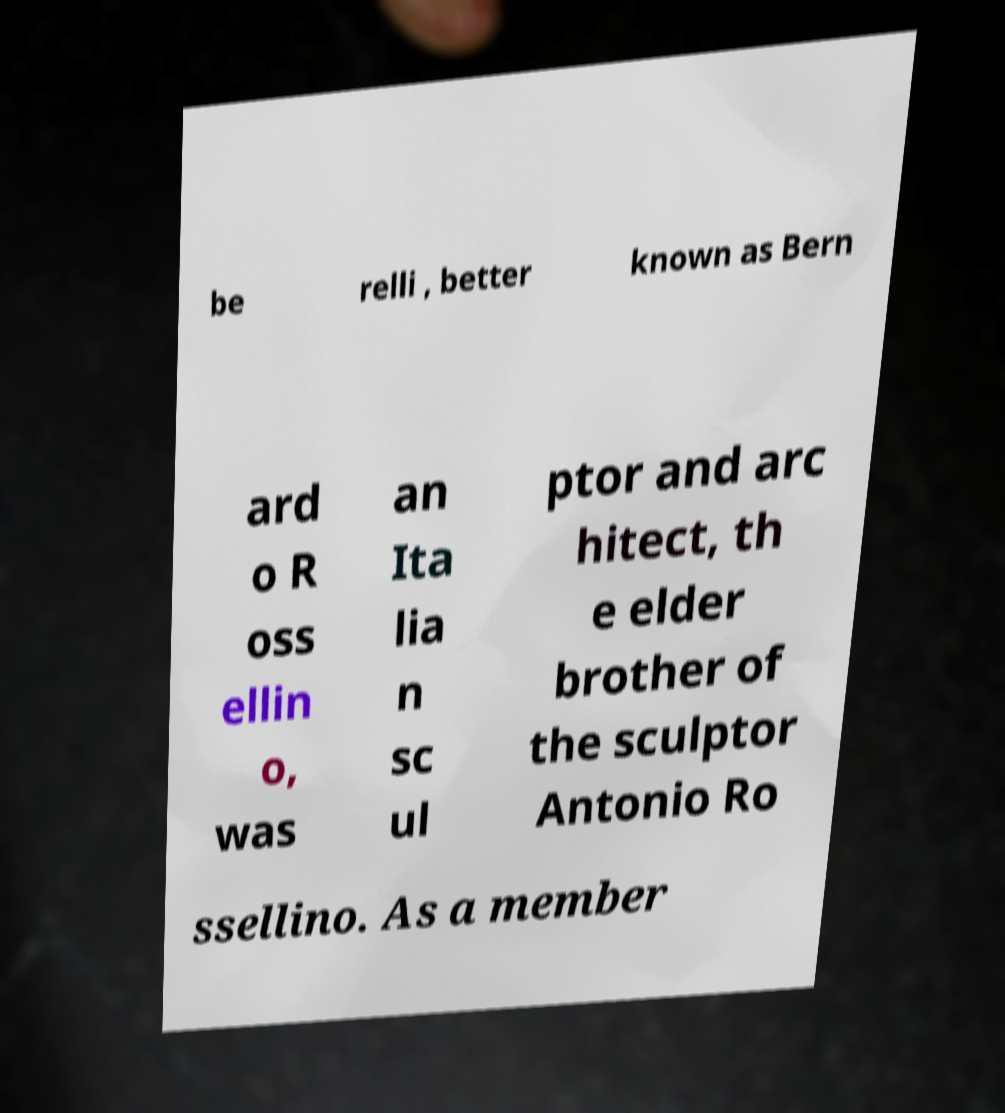Please identify and transcribe the text found in this image. be relli , better known as Bern ard o R oss ellin o, was an Ita lia n sc ul ptor and arc hitect, th e elder brother of the sculptor Antonio Ro ssellino. As a member 